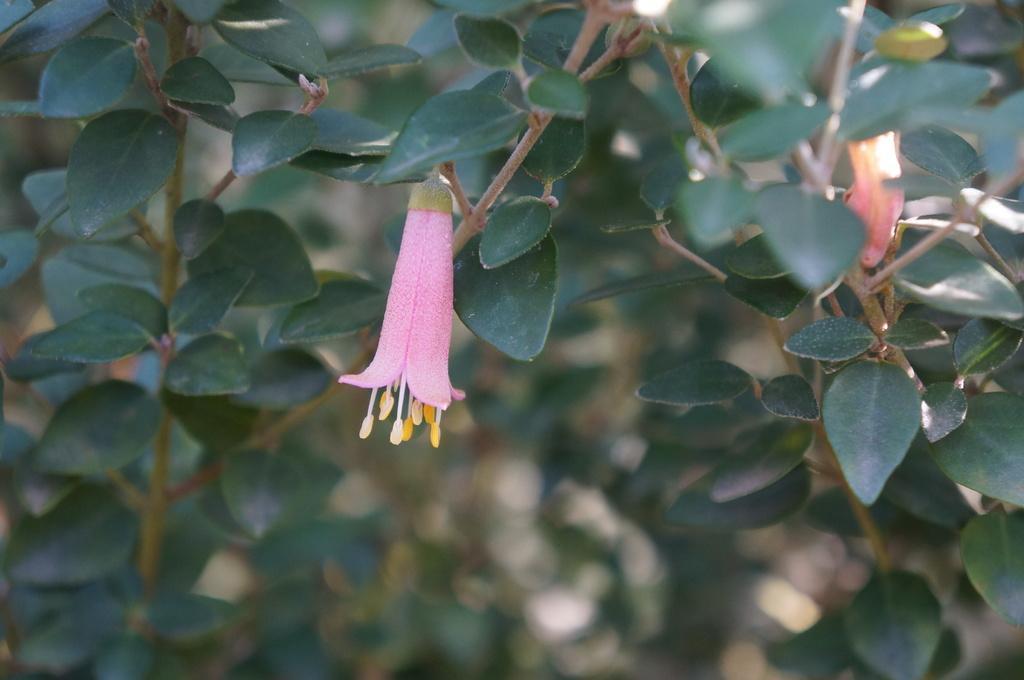Could you give a brief overview of what you see in this image? In this image there is a small pink flower in the middle. In the background there are plants. 